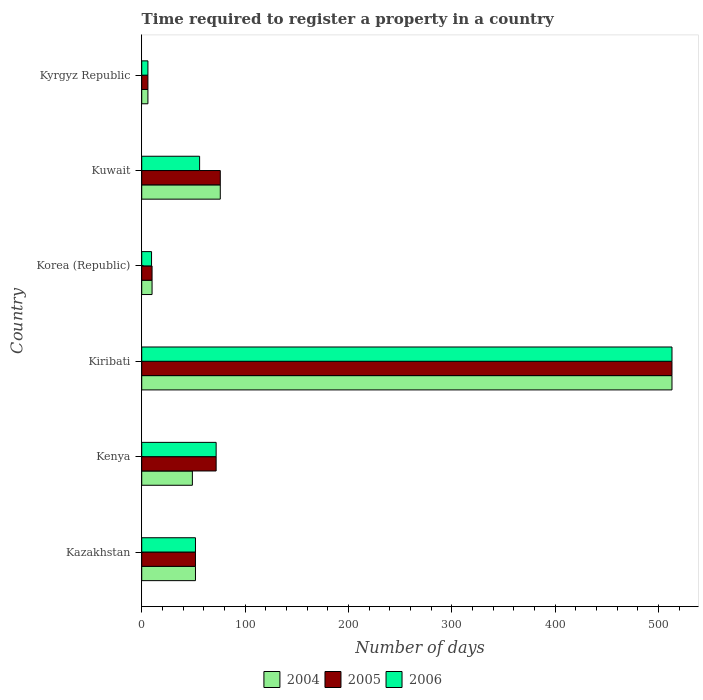How many groups of bars are there?
Offer a very short reply. 6. Are the number of bars per tick equal to the number of legend labels?
Your answer should be very brief. Yes. Are the number of bars on each tick of the Y-axis equal?
Give a very brief answer. Yes. How many bars are there on the 2nd tick from the top?
Your answer should be compact. 3. What is the label of the 5th group of bars from the top?
Ensure brevity in your answer.  Kenya. In how many cases, is the number of bars for a given country not equal to the number of legend labels?
Provide a succinct answer. 0. What is the number of days required to register a property in 2005 in Korea (Republic)?
Ensure brevity in your answer.  10. Across all countries, what is the maximum number of days required to register a property in 2006?
Your response must be concise. 513. Across all countries, what is the minimum number of days required to register a property in 2005?
Your answer should be compact. 6. In which country was the number of days required to register a property in 2006 maximum?
Keep it short and to the point. Kiribati. In which country was the number of days required to register a property in 2004 minimum?
Give a very brief answer. Kyrgyz Republic. What is the total number of days required to register a property in 2005 in the graph?
Keep it short and to the point. 729. What is the difference between the number of days required to register a property in 2004 in Kenya and that in Kyrgyz Republic?
Keep it short and to the point. 43. What is the difference between the number of days required to register a property in 2004 in Kenya and the number of days required to register a property in 2006 in Korea (Republic)?
Provide a succinct answer. 39.5. What is the average number of days required to register a property in 2004 per country?
Offer a very short reply. 117.67. What is the difference between the number of days required to register a property in 2006 and number of days required to register a property in 2004 in Kiribati?
Give a very brief answer. 0. In how many countries, is the number of days required to register a property in 2004 greater than 500 days?
Ensure brevity in your answer.  1. What is the ratio of the number of days required to register a property in 2006 in Kenya to that in Kiribati?
Your response must be concise. 0.14. Is the number of days required to register a property in 2004 in Kuwait less than that in Kyrgyz Republic?
Your answer should be very brief. No. What is the difference between the highest and the second highest number of days required to register a property in 2004?
Your answer should be very brief. 437. What is the difference between the highest and the lowest number of days required to register a property in 2004?
Provide a short and direct response. 507. In how many countries, is the number of days required to register a property in 2004 greater than the average number of days required to register a property in 2004 taken over all countries?
Your answer should be very brief. 1. What does the 3rd bar from the top in Kazakhstan represents?
Make the answer very short. 2004. What does the 3rd bar from the bottom in Korea (Republic) represents?
Your answer should be very brief. 2006. Is it the case that in every country, the sum of the number of days required to register a property in 2006 and number of days required to register a property in 2005 is greater than the number of days required to register a property in 2004?
Your answer should be very brief. Yes. How many bars are there?
Make the answer very short. 18. Are all the bars in the graph horizontal?
Keep it short and to the point. Yes. How many countries are there in the graph?
Your answer should be very brief. 6. What is the difference between two consecutive major ticks on the X-axis?
Give a very brief answer. 100. Are the values on the major ticks of X-axis written in scientific E-notation?
Your answer should be compact. No. Does the graph contain any zero values?
Provide a succinct answer. No. What is the title of the graph?
Your answer should be very brief. Time required to register a property in a country. Does "1990" appear as one of the legend labels in the graph?
Make the answer very short. No. What is the label or title of the X-axis?
Ensure brevity in your answer.  Number of days. What is the Number of days in 2004 in Kazakhstan?
Provide a succinct answer. 52. What is the Number of days in 2006 in Kazakhstan?
Ensure brevity in your answer.  52. What is the Number of days of 2004 in Kiribati?
Provide a succinct answer. 513. What is the Number of days in 2005 in Kiribati?
Make the answer very short. 513. What is the Number of days of 2006 in Kiribati?
Ensure brevity in your answer.  513. What is the Number of days in 2005 in Korea (Republic)?
Provide a succinct answer. 10. What is the Number of days in 2005 in Kuwait?
Make the answer very short. 76. What is the Number of days of 2004 in Kyrgyz Republic?
Your answer should be very brief. 6. What is the Number of days of 2005 in Kyrgyz Republic?
Your answer should be very brief. 6. What is the Number of days of 2006 in Kyrgyz Republic?
Provide a succinct answer. 6. Across all countries, what is the maximum Number of days of 2004?
Offer a terse response. 513. Across all countries, what is the maximum Number of days in 2005?
Provide a succinct answer. 513. Across all countries, what is the maximum Number of days in 2006?
Give a very brief answer. 513. Across all countries, what is the minimum Number of days of 2004?
Provide a succinct answer. 6. Across all countries, what is the minimum Number of days of 2006?
Give a very brief answer. 6. What is the total Number of days of 2004 in the graph?
Ensure brevity in your answer.  706. What is the total Number of days of 2005 in the graph?
Your answer should be compact. 729. What is the total Number of days in 2006 in the graph?
Your response must be concise. 708.5. What is the difference between the Number of days in 2004 in Kazakhstan and that in Kenya?
Offer a very short reply. 3. What is the difference between the Number of days in 2005 in Kazakhstan and that in Kenya?
Provide a short and direct response. -20. What is the difference between the Number of days in 2004 in Kazakhstan and that in Kiribati?
Offer a very short reply. -461. What is the difference between the Number of days in 2005 in Kazakhstan and that in Kiribati?
Keep it short and to the point. -461. What is the difference between the Number of days in 2006 in Kazakhstan and that in Kiribati?
Offer a very short reply. -461. What is the difference between the Number of days in 2004 in Kazakhstan and that in Korea (Republic)?
Ensure brevity in your answer.  42. What is the difference between the Number of days in 2006 in Kazakhstan and that in Korea (Republic)?
Offer a terse response. 42.5. What is the difference between the Number of days in 2004 in Kazakhstan and that in Kuwait?
Give a very brief answer. -24. What is the difference between the Number of days of 2005 in Kazakhstan and that in Kuwait?
Your answer should be very brief. -24. What is the difference between the Number of days in 2006 in Kazakhstan and that in Kuwait?
Keep it short and to the point. -4. What is the difference between the Number of days in 2004 in Kazakhstan and that in Kyrgyz Republic?
Your answer should be compact. 46. What is the difference between the Number of days of 2004 in Kenya and that in Kiribati?
Provide a succinct answer. -464. What is the difference between the Number of days in 2005 in Kenya and that in Kiribati?
Give a very brief answer. -441. What is the difference between the Number of days of 2006 in Kenya and that in Kiribati?
Provide a succinct answer. -441. What is the difference between the Number of days in 2006 in Kenya and that in Korea (Republic)?
Give a very brief answer. 62.5. What is the difference between the Number of days of 2004 in Kenya and that in Kuwait?
Offer a very short reply. -27. What is the difference between the Number of days in 2005 in Kenya and that in Kuwait?
Keep it short and to the point. -4. What is the difference between the Number of days in 2006 in Kenya and that in Kuwait?
Provide a short and direct response. 16. What is the difference between the Number of days in 2004 in Kenya and that in Kyrgyz Republic?
Keep it short and to the point. 43. What is the difference between the Number of days in 2005 in Kenya and that in Kyrgyz Republic?
Ensure brevity in your answer.  66. What is the difference between the Number of days of 2006 in Kenya and that in Kyrgyz Republic?
Keep it short and to the point. 66. What is the difference between the Number of days of 2004 in Kiribati and that in Korea (Republic)?
Give a very brief answer. 503. What is the difference between the Number of days of 2005 in Kiribati and that in Korea (Republic)?
Keep it short and to the point. 503. What is the difference between the Number of days of 2006 in Kiribati and that in Korea (Republic)?
Offer a terse response. 503.5. What is the difference between the Number of days of 2004 in Kiribati and that in Kuwait?
Your response must be concise. 437. What is the difference between the Number of days in 2005 in Kiribati and that in Kuwait?
Offer a terse response. 437. What is the difference between the Number of days of 2006 in Kiribati and that in Kuwait?
Ensure brevity in your answer.  457. What is the difference between the Number of days of 2004 in Kiribati and that in Kyrgyz Republic?
Keep it short and to the point. 507. What is the difference between the Number of days in 2005 in Kiribati and that in Kyrgyz Republic?
Provide a short and direct response. 507. What is the difference between the Number of days in 2006 in Kiribati and that in Kyrgyz Republic?
Your answer should be compact. 507. What is the difference between the Number of days of 2004 in Korea (Republic) and that in Kuwait?
Provide a succinct answer. -66. What is the difference between the Number of days in 2005 in Korea (Republic) and that in Kuwait?
Offer a very short reply. -66. What is the difference between the Number of days in 2006 in Korea (Republic) and that in Kuwait?
Give a very brief answer. -46.5. What is the difference between the Number of days of 2005 in Korea (Republic) and that in Kyrgyz Republic?
Your answer should be very brief. 4. What is the difference between the Number of days of 2006 in Korea (Republic) and that in Kyrgyz Republic?
Keep it short and to the point. 3.5. What is the difference between the Number of days in 2004 in Kuwait and that in Kyrgyz Republic?
Provide a succinct answer. 70. What is the difference between the Number of days of 2005 in Kuwait and that in Kyrgyz Republic?
Give a very brief answer. 70. What is the difference between the Number of days in 2004 in Kazakhstan and the Number of days in 2005 in Kiribati?
Ensure brevity in your answer.  -461. What is the difference between the Number of days of 2004 in Kazakhstan and the Number of days of 2006 in Kiribati?
Offer a very short reply. -461. What is the difference between the Number of days of 2005 in Kazakhstan and the Number of days of 2006 in Kiribati?
Offer a very short reply. -461. What is the difference between the Number of days in 2004 in Kazakhstan and the Number of days in 2005 in Korea (Republic)?
Provide a succinct answer. 42. What is the difference between the Number of days in 2004 in Kazakhstan and the Number of days in 2006 in Korea (Republic)?
Provide a succinct answer. 42.5. What is the difference between the Number of days of 2005 in Kazakhstan and the Number of days of 2006 in Korea (Republic)?
Make the answer very short. 42.5. What is the difference between the Number of days in 2004 in Kazakhstan and the Number of days in 2005 in Kuwait?
Offer a terse response. -24. What is the difference between the Number of days of 2004 in Kazakhstan and the Number of days of 2006 in Kuwait?
Keep it short and to the point. -4. What is the difference between the Number of days of 2004 in Kazakhstan and the Number of days of 2005 in Kyrgyz Republic?
Give a very brief answer. 46. What is the difference between the Number of days in 2004 in Kenya and the Number of days in 2005 in Kiribati?
Ensure brevity in your answer.  -464. What is the difference between the Number of days in 2004 in Kenya and the Number of days in 2006 in Kiribati?
Ensure brevity in your answer.  -464. What is the difference between the Number of days in 2005 in Kenya and the Number of days in 2006 in Kiribati?
Give a very brief answer. -441. What is the difference between the Number of days of 2004 in Kenya and the Number of days of 2005 in Korea (Republic)?
Offer a terse response. 39. What is the difference between the Number of days in 2004 in Kenya and the Number of days in 2006 in Korea (Republic)?
Offer a terse response. 39.5. What is the difference between the Number of days in 2005 in Kenya and the Number of days in 2006 in Korea (Republic)?
Your answer should be compact. 62.5. What is the difference between the Number of days in 2004 in Kenya and the Number of days in 2005 in Kuwait?
Your answer should be compact. -27. What is the difference between the Number of days of 2005 in Kenya and the Number of days of 2006 in Kuwait?
Your answer should be very brief. 16. What is the difference between the Number of days in 2004 in Kenya and the Number of days in 2006 in Kyrgyz Republic?
Your answer should be very brief. 43. What is the difference between the Number of days in 2004 in Kiribati and the Number of days in 2005 in Korea (Republic)?
Your response must be concise. 503. What is the difference between the Number of days in 2004 in Kiribati and the Number of days in 2006 in Korea (Republic)?
Your answer should be very brief. 503.5. What is the difference between the Number of days of 2005 in Kiribati and the Number of days of 2006 in Korea (Republic)?
Provide a succinct answer. 503.5. What is the difference between the Number of days in 2004 in Kiribati and the Number of days in 2005 in Kuwait?
Provide a succinct answer. 437. What is the difference between the Number of days in 2004 in Kiribati and the Number of days in 2006 in Kuwait?
Your answer should be compact. 457. What is the difference between the Number of days in 2005 in Kiribati and the Number of days in 2006 in Kuwait?
Offer a very short reply. 457. What is the difference between the Number of days of 2004 in Kiribati and the Number of days of 2005 in Kyrgyz Republic?
Make the answer very short. 507. What is the difference between the Number of days of 2004 in Kiribati and the Number of days of 2006 in Kyrgyz Republic?
Keep it short and to the point. 507. What is the difference between the Number of days of 2005 in Kiribati and the Number of days of 2006 in Kyrgyz Republic?
Give a very brief answer. 507. What is the difference between the Number of days in 2004 in Korea (Republic) and the Number of days in 2005 in Kuwait?
Give a very brief answer. -66. What is the difference between the Number of days of 2004 in Korea (Republic) and the Number of days of 2006 in Kuwait?
Your answer should be compact. -46. What is the difference between the Number of days of 2005 in Korea (Republic) and the Number of days of 2006 in Kuwait?
Give a very brief answer. -46. What is the difference between the Number of days in 2005 in Korea (Republic) and the Number of days in 2006 in Kyrgyz Republic?
Offer a very short reply. 4. What is the difference between the Number of days in 2004 in Kuwait and the Number of days in 2005 in Kyrgyz Republic?
Keep it short and to the point. 70. What is the average Number of days in 2004 per country?
Provide a short and direct response. 117.67. What is the average Number of days of 2005 per country?
Provide a short and direct response. 121.5. What is the average Number of days in 2006 per country?
Provide a succinct answer. 118.08. What is the difference between the Number of days of 2004 and Number of days of 2005 in Kazakhstan?
Ensure brevity in your answer.  0. What is the difference between the Number of days of 2004 and Number of days of 2006 in Kazakhstan?
Ensure brevity in your answer.  0. What is the difference between the Number of days of 2004 and Number of days of 2005 in Kenya?
Offer a terse response. -23. What is the difference between the Number of days of 2004 and Number of days of 2006 in Kenya?
Give a very brief answer. -23. What is the difference between the Number of days in 2004 and Number of days in 2005 in Kiribati?
Keep it short and to the point. 0. What is the difference between the Number of days of 2005 and Number of days of 2006 in Kiribati?
Make the answer very short. 0. What is the difference between the Number of days in 2004 and Number of days in 2006 in Korea (Republic)?
Make the answer very short. 0.5. What is the difference between the Number of days in 2004 and Number of days in 2005 in Kuwait?
Give a very brief answer. 0. What is the difference between the Number of days of 2005 and Number of days of 2006 in Kuwait?
Give a very brief answer. 20. What is the difference between the Number of days of 2004 and Number of days of 2006 in Kyrgyz Republic?
Keep it short and to the point. 0. What is the difference between the Number of days in 2005 and Number of days in 2006 in Kyrgyz Republic?
Provide a short and direct response. 0. What is the ratio of the Number of days in 2004 in Kazakhstan to that in Kenya?
Provide a short and direct response. 1.06. What is the ratio of the Number of days of 2005 in Kazakhstan to that in Kenya?
Offer a very short reply. 0.72. What is the ratio of the Number of days of 2006 in Kazakhstan to that in Kenya?
Keep it short and to the point. 0.72. What is the ratio of the Number of days in 2004 in Kazakhstan to that in Kiribati?
Keep it short and to the point. 0.1. What is the ratio of the Number of days of 2005 in Kazakhstan to that in Kiribati?
Offer a terse response. 0.1. What is the ratio of the Number of days of 2006 in Kazakhstan to that in Kiribati?
Offer a very short reply. 0.1. What is the ratio of the Number of days in 2005 in Kazakhstan to that in Korea (Republic)?
Your response must be concise. 5.2. What is the ratio of the Number of days of 2006 in Kazakhstan to that in Korea (Republic)?
Give a very brief answer. 5.47. What is the ratio of the Number of days of 2004 in Kazakhstan to that in Kuwait?
Provide a succinct answer. 0.68. What is the ratio of the Number of days of 2005 in Kazakhstan to that in Kuwait?
Offer a very short reply. 0.68. What is the ratio of the Number of days in 2004 in Kazakhstan to that in Kyrgyz Republic?
Your answer should be very brief. 8.67. What is the ratio of the Number of days in 2005 in Kazakhstan to that in Kyrgyz Republic?
Make the answer very short. 8.67. What is the ratio of the Number of days in 2006 in Kazakhstan to that in Kyrgyz Republic?
Your response must be concise. 8.67. What is the ratio of the Number of days of 2004 in Kenya to that in Kiribati?
Keep it short and to the point. 0.1. What is the ratio of the Number of days in 2005 in Kenya to that in Kiribati?
Your answer should be compact. 0.14. What is the ratio of the Number of days of 2006 in Kenya to that in Kiribati?
Your answer should be compact. 0.14. What is the ratio of the Number of days in 2006 in Kenya to that in Korea (Republic)?
Give a very brief answer. 7.58. What is the ratio of the Number of days of 2004 in Kenya to that in Kuwait?
Provide a succinct answer. 0.64. What is the ratio of the Number of days in 2005 in Kenya to that in Kuwait?
Offer a very short reply. 0.95. What is the ratio of the Number of days in 2006 in Kenya to that in Kuwait?
Give a very brief answer. 1.29. What is the ratio of the Number of days in 2004 in Kenya to that in Kyrgyz Republic?
Provide a short and direct response. 8.17. What is the ratio of the Number of days of 2005 in Kenya to that in Kyrgyz Republic?
Offer a very short reply. 12. What is the ratio of the Number of days in 2006 in Kenya to that in Kyrgyz Republic?
Offer a terse response. 12. What is the ratio of the Number of days of 2004 in Kiribati to that in Korea (Republic)?
Provide a short and direct response. 51.3. What is the ratio of the Number of days in 2005 in Kiribati to that in Korea (Republic)?
Provide a succinct answer. 51.3. What is the ratio of the Number of days of 2004 in Kiribati to that in Kuwait?
Ensure brevity in your answer.  6.75. What is the ratio of the Number of days of 2005 in Kiribati to that in Kuwait?
Offer a terse response. 6.75. What is the ratio of the Number of days of 2006 in Kiribati to that in Kuwait?
Give a very brief answer. 9.16. What is the ratio of the Number of days of 2004 in Kiribati to that in Kyrgyz Republic?
Your answer should be compact. 85.5. What is the ratio of the Number of days of 2005 in Kiribati to that in Kyrgyz Republic?
Provide a succinct answer. 85.5. What is the ratio of the Number of days of 2006 in Kiribati to that in Kyrgyz Republic?
Your response must be concise. 85.5. What is the ratio of the Number of days of 2004 in Korea (Republic) to that in Kuwait?
Keep it short and to the point. 0.13. What is the ratio of the Number of days in 2005 in Korea (Republic) to that in Kuwait?
Your response must be concise. 0.13. What is the ratio of the Number of days of 2006 in Korea (Republic) to that in Kuwait?
Offer a terse response. 0.17. What is the ratio of the Number of days of 2006 in Korea (Republic) to that in Kyrgyz Republic?
Give a very brief answer. 1.58. What is the ratio of the Number of days in 2004 in Kuwait to that in Kyrgyz Republic?
Provide a succinct answer. 12.67. What is the ratio of the Number of days in 2005 in Kuwait to that in Kyrgyz Republic?
Provide a succinct answer. 12.67. What is the ratio of the Number of days of 2006 in Kuwait to that in Kyrgyz Republic?
Your response must be concise. 9.33. What is the difference between the highest and the second highest Number of days of 2004?
Make the answer very short. 437. What is the difference between the highest and the second highest Number of days in 2005?
Your response must be concise. 437. What is the difference between the highest and the second highest Number of days of 2006?
Your response must be concise. 441. What is the difference between the highest and the lowest Number of days in 2004?
Your answer should be compact. 507. What is the difference between the highest and the lowest Number of days in 2005?
Your answer should be compact. 507. What is the difference between the highest and the lowest Number of days in 2006?
Keep it short and to the point. 507. 